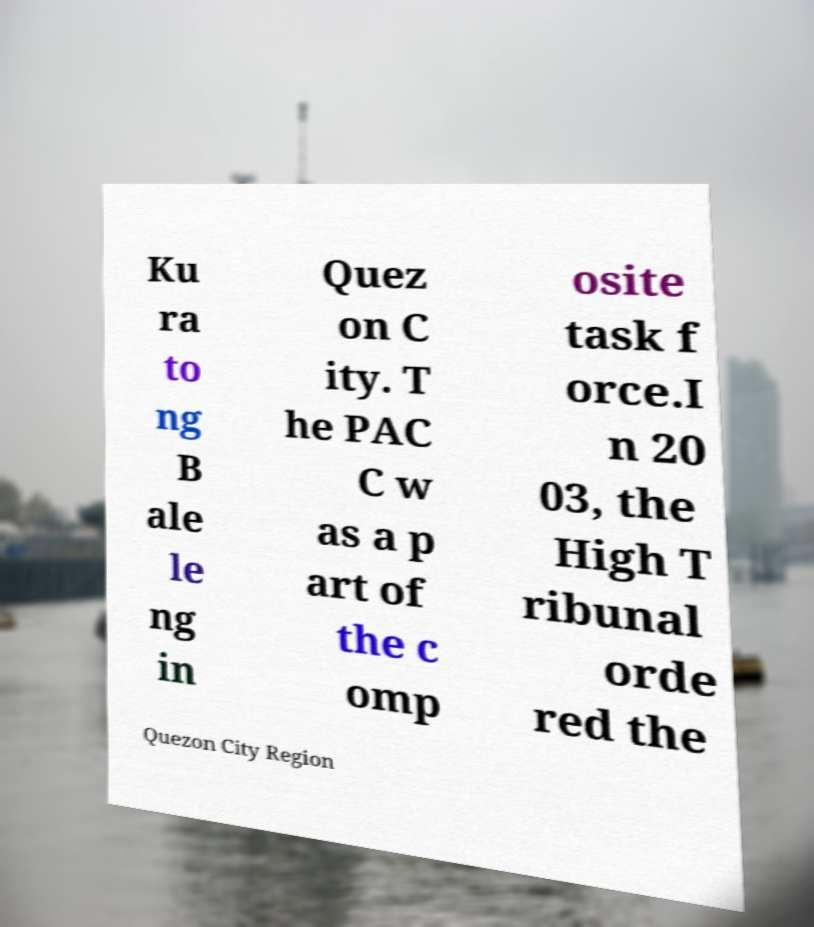There's text embedded in this image that I need extracted. Can you transcribe it verbatim? Ku ra to ng B ale le ng in Quez on C ity. T he PAC C w as a p art of the c omp osite task f orce.I n 20 03, the High T ribunal orde red the Quezon City Region 